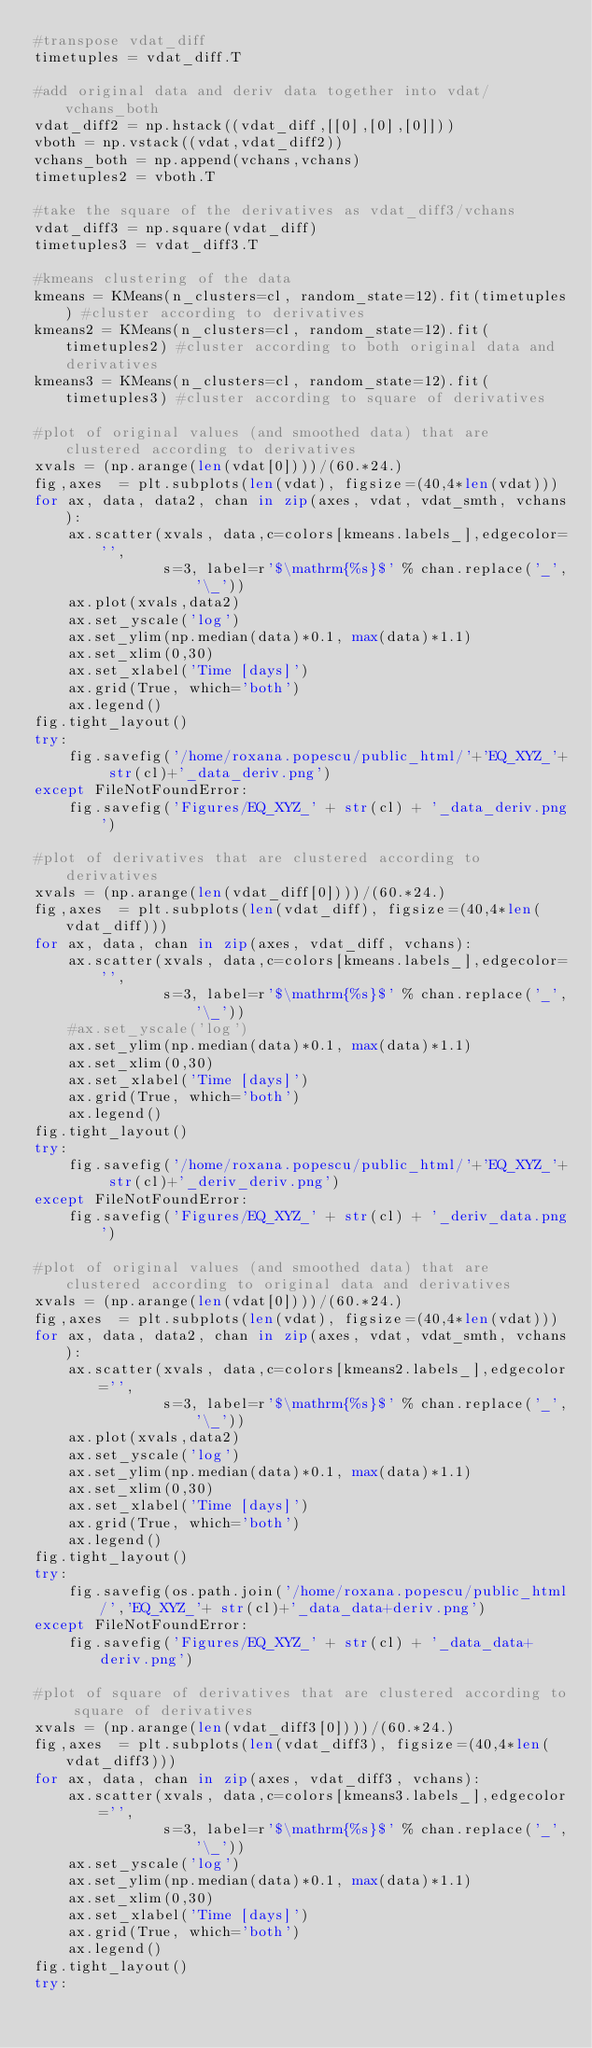Convert code to text. <code><loc_0><loc_0><loc_500><loc_500><_Python_>#transpose vdat_diff
timetuples = vdat_diff.T

#add original data and deriv data together into vdat/vchans_both
vdat_diff2 = np.hstack((vdat_diff,[[0],[0],[0]]))
vboth = np.vstack((vdat,vdat_diff2))
vchans_both = np.append(vchans,vchans)
timetuples2 = vboth.T

#take the square of the derivatives as vdat_diff3/vchans
vdat_diff3 = np.square(vdat_diff)
timetuples3 = vdat_diff3.T

#kmeans clustering of the data 
kmeans = KMeans(n_clusters=cl, random_state=12).fit(timetuples) #cluster according to derivatives
kmeans2 = KMeans(n_clusters=cl, random_state=12).fit(timetuples2) #cluster according to both original data and derivatives
kmeans3 = KMeans(n_clusters=cl, random_state=12).fit(timetuples3) #cluster according to square of derivatives

#plot of original values (and smoothed data) that are clustered according to derivatives
xvals = (np.arange(len(vdat[0])))/(60.*24.)
fig,axes  = plt.subplots(len(vdat), figsize=(40,4*len(vdat)))
for ax, data, data2, chan in zip(axes, vdat, vdat_smth, vchans):
    ax.scatter(xvals, data,c=colors[kmeans.labels_],edgecolor='',
               s=3, label=r'$\mathrm{%s}$' % chan.replace('_','\_'))
    ax.plot(xvals,data2)
    ax.set_yscale('log')
    ax.set_ylim(np.median(data)*0.1, max(data)*1.1)
    ax.set_xlim(0,30)
    ax.set_xlabel('Time [days]')
    ax.grid(True, which='both')
    ax.legend()
fig.tight_layout()
try:
    fig.savefig('/home/roxana.popescu/public_html/'+'EQ_XYZ_'+ str(cl)+'_data_deriv.png')
except FileNotFoundError:
    fig.savefig('Figures/EQ_XYZ_' + str(cl) + '_data_deriv.png')

#plot of derivatives that are clustered according to derivatives 
xvals = (np.arange(len(vdat_diff[0])))/(60.*24.)
fig,axes  = plt.subplots(len(vdat_diff), figsize=(40,4*len(vdat_diff)))
for ax, data, chan in zip(axes, vdat_diff, vchans):
    ax.scatter(xvals, data,c=colors[kmeans.labels_],edgecolor='',
               s=3, label=r'$\mathrm{%s}$' % chan.replace('_','\_'))
    #ax.set_yscale('log')
    ax.set_ylim(np.median(data)*0.1, max(data)*1.1)
    ax.set_xlim(0,30)
    ax.set_xlabel('Time [days]')
    ax.grid(True, which='both')
    ax.legend()
fig.tight_layout()
try:
    fig.savefig('/home/roxana.popescu/public_html/'+'EQ_XYZ_'+ str(cl)+'_deriv_deriv.png')
except FileNotFoundError:
    fig.savefig('Figures/EQ_XYZ_' + str(cl) + '_deriv_data.png')

#plot of original values (and smoothed data) that are clustered according to original data and derivatives
xvals = (np.arange(len(vdat[0])))/(60.*24.)
fig,axes  = plt.subplots(len(vdat), figsize=(40,4*len(vdat)))
for ax, data, data2, chan in zip(axes, vdat, vdat_smth, vchans):
    ax.scatter(xvals, data,c=colors[kmeans2.labels_],edgecolor='',
               s=3, label=r'$\mathrm{%s}$' % chan.replace('_','\_'))
    ax.plot(xvals,data2)
    ax.set_yscale('log')
    ax.set_ylim(np.median(data)*0.1, max(data)*1.1)
    ax.set_xlim(0,30)
    ax.set_xlabel('Time [days]')
    ax.grid(True, which='both')
    ax.legend()
fig.tight_layout()
try:
    fig.savefig(os.path.join('/home/roxana.popescu/public_html/','EQ_XYZ_'+ str(cl)+'_data_data+deriv.png')
except FileNotFoundError:
    fig.savefig('Figures/EQ_XYZ_' + str(cl) + '_data_data+deriv.png')

#plot of square of derivatives that are clustered according to square of derivatives
xvals = (np.arange(len(vdat_diff3[0])))/(60.*24.)
fig,axes  = plt.subplots(len(vdat_diff3), figsize=(40,4*len(vdat_diff3)))
for ax, data, chan in zip(axes, vdat_diff3, vchans):
    ax.scatter(xvals, data,c=colors[kmeans3.labels_],edgecolor='',
               s=3, label=r'$\mathrm{%s}$' % chan.replace('_','\_'))
    ax.set_yscale('log')
    ax.set_ylim(np.median(data)*0.1, max(data)*1.1)
    ax.set_xlim(0,30)
    ax.set_xlabel('Time [days]')
    ax.grid(True, which='both')
    ax.legend()
fig.tight_layout()
try:</code> 